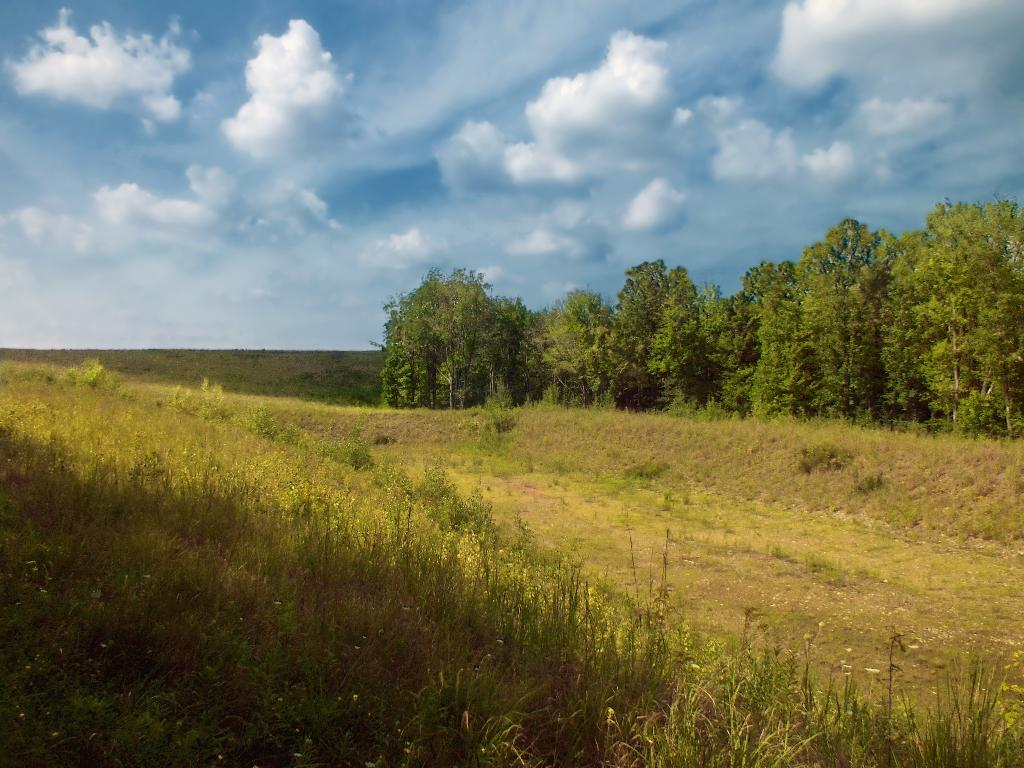What type of vegetation can be seen in the image? There are trees in the image. What is covering the ground in the image? The ground is covered with grass in the image. What can be seen in the sky in the image? There are clouds in the sky in the image. Are there any fairies visible in the image? There are no fairies present in the image. What type of arch can be seen in the image? There is no arch present in the image. 